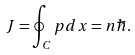Convert formula to latex. <formula><loc_0><loc_0><loc_500><loc_500>J = \oint _ { C } p d x = n \hbar { . }</formula> 